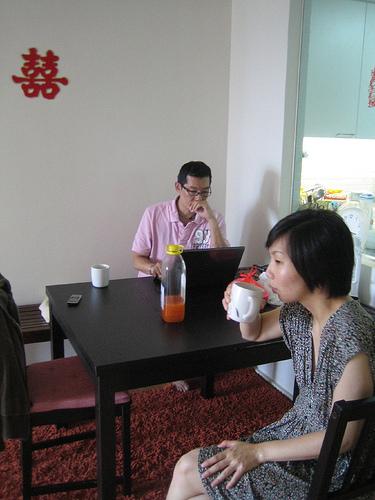What is the man working on?
Quick response, please. Laptop. Are they enjoying each others company?
Short answer required. No. How many cups are on the table?
Keep it brief. 1. 